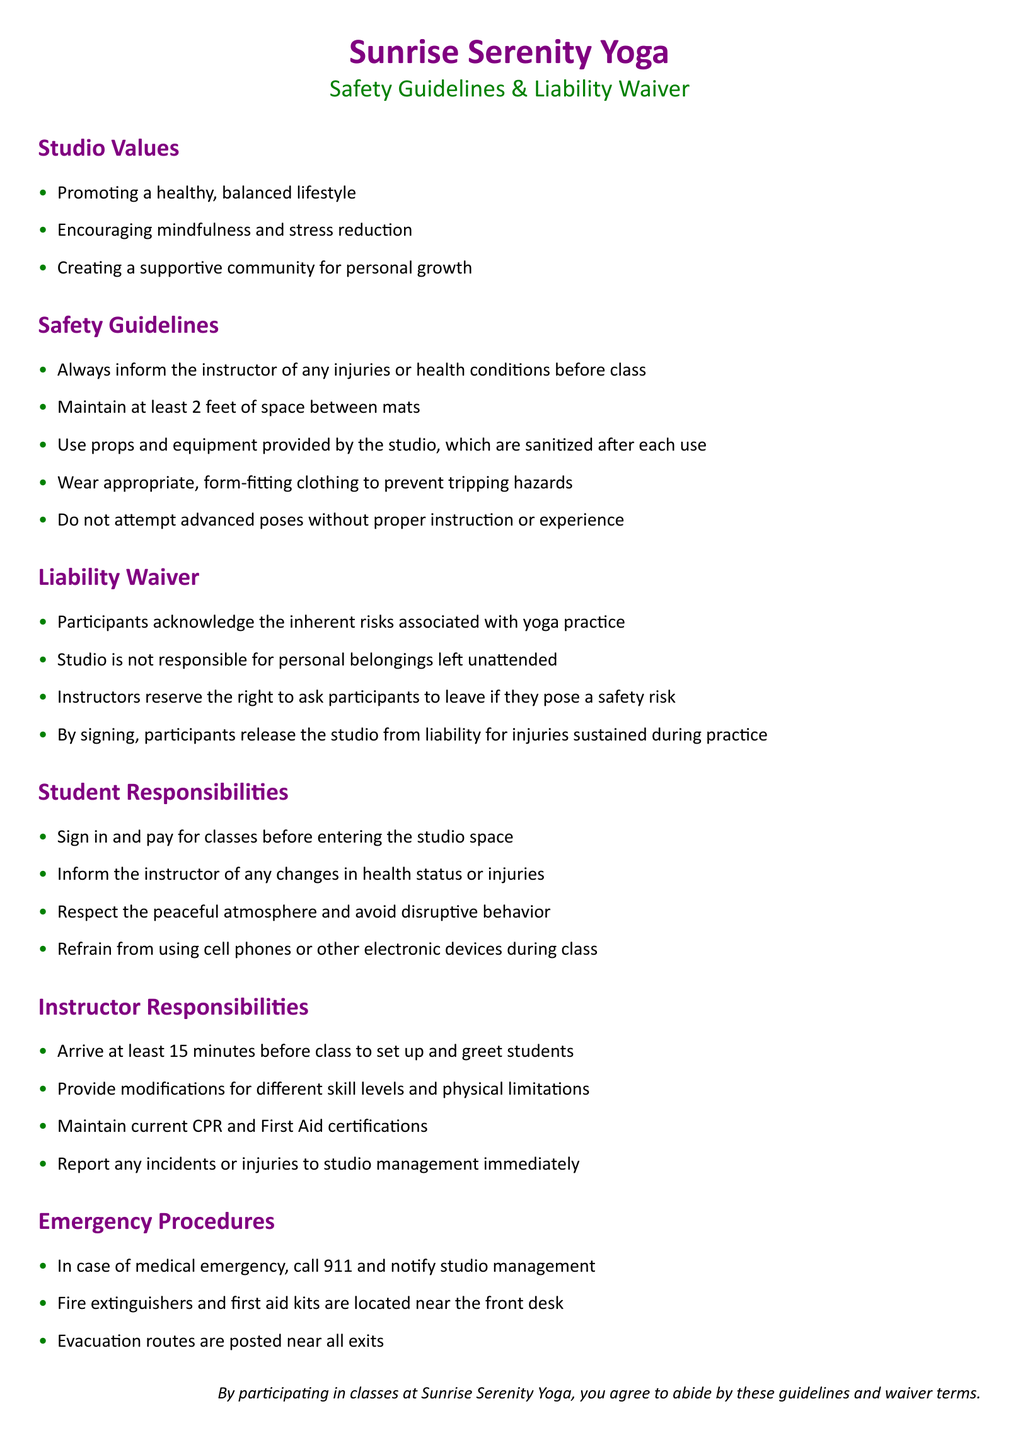What are the studio values? The studio values are the principles that guide the conduct and philosophy of the yoga studio, listed in the "Studio Values" section.
Answer: Promoting a healthy, balanced lifestyle; Encouraging mindfulness and stress reduction; Creating a supportive community for personal growth What must participants inform the instructor about? This information can be found under the "Safety Guidelines" section, which specifies what participants should communicate to their instructors before class.
Answer: Any injuries or health conditions How far should mats be spaced? The required spacing is indicated in the "Safety Guidelines" section.
Answer: At least 2 feet What do participants acknowledge by signing the liability waiver? This information is located in the "Liability Waiver" section, explaining what participants agree to upon signing.
Answer: Inherent risks associated with yoga practice What should instructors maintain to ensure safety? The requirement for instructors is detailed in the "Instructor Responsibilities" section of the document.
Answer: Current CPR and First Aid certifications What should participants do with their belongings? This guideline is noted in the "Liability Waiver" section about personal belongings.
Answer: Studio is not responsible What is the first step for students upon entering the studio? This information is found in the "Student Responsibilities" section which outlines what students must do.
Answer: Sign in and pay for classes What is located near the front desk according to emergency procedures? This detail is described in the "Emergency Procedures" section, outlining safety equipment locations.
Answer: Fire extinguishers and first aid kits What action should be taken in case of a medical emergency? The procedure to be followed during a medical emergency is mentioned in the "Emergency Procedures" section.
Answer: Call 911 and notify studio management 